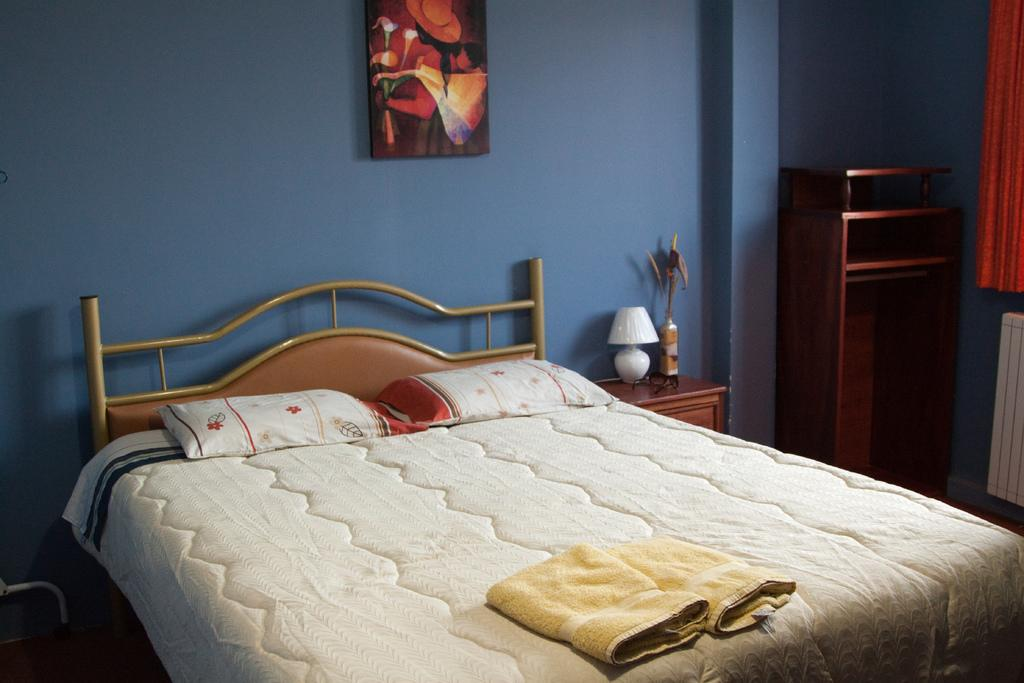What piece of furniture is present in the image? There is a bed in the image. What is placed on the bed? There are two pillows on the bed. What items can be seen in addition to the bed? There are two towels, a lamp, a curtain, and a painting on the wall in the image. What type of stick can be seen in the mouth of the person in the image? There is no person or stick present in the image. 